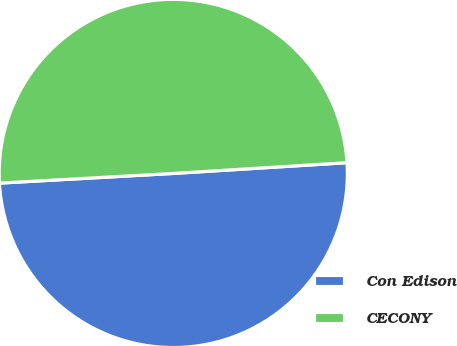Convert chart to OTSL. <chart><loc_0><loc_0><loc_500><loc_500><pie_chart><fcel>Con Edison<fcel>CECONY<nl><fcel>50.1%<fcel>49.9%<nl></chart> 